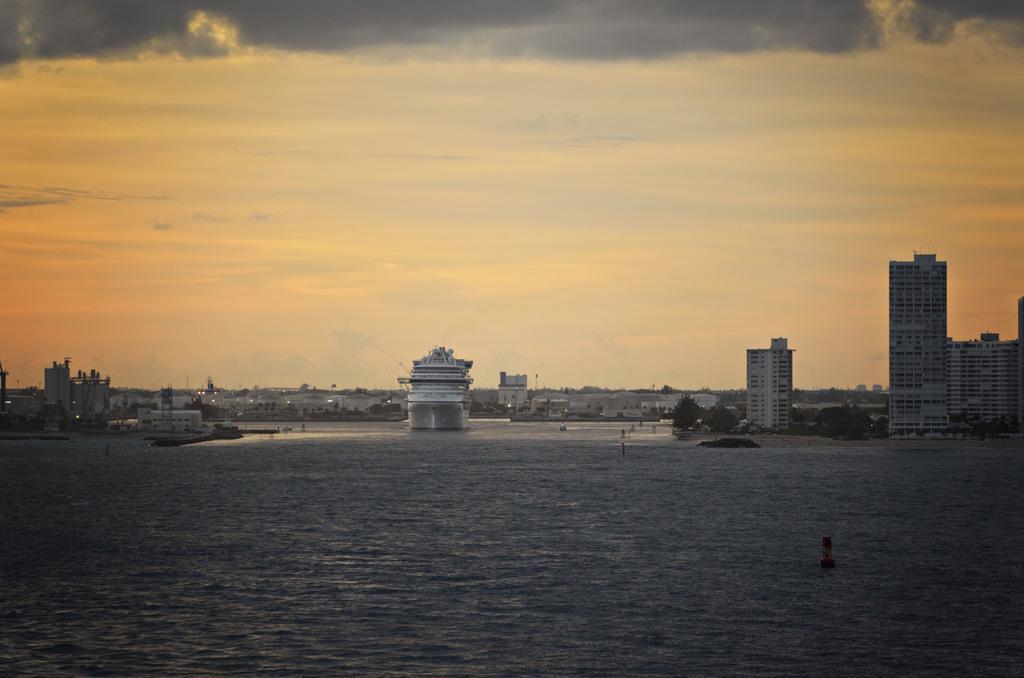Could you give a brief overview of what you see in this image? Here in this picture we can see ships present in water over there and we can see buildings and houses in the far and we can see trees and plants also present over there and we can see clouds in sky. 